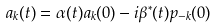<formula> <loc_0><loc_0><loc_500><loc_500>a _ { k } ( t ) = \alpha ( t ) a _ { k } ( 0 ) - i \beta ^ { * } ( t ) p _ { - k } ( 0 )</formula> 